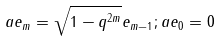<formula> <loc_0><loc_0><loc_500><loc_500>a e _ { m } = \sqrt { 1 - q ^ { 2 m } } e _ { m - 1 } ; a e _ { 0 } = 0</formula> 